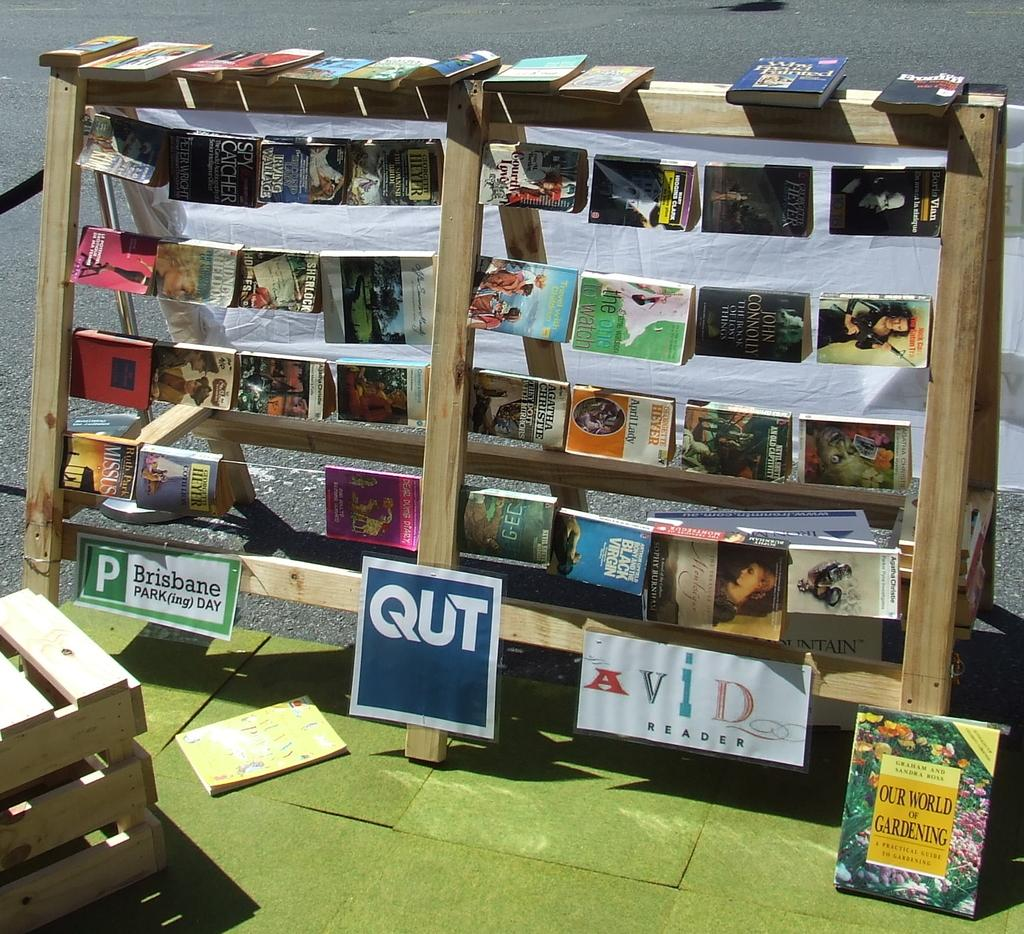<image>
Summarize the visual content of the image. Bookshelf of books on the outside Avid reader 